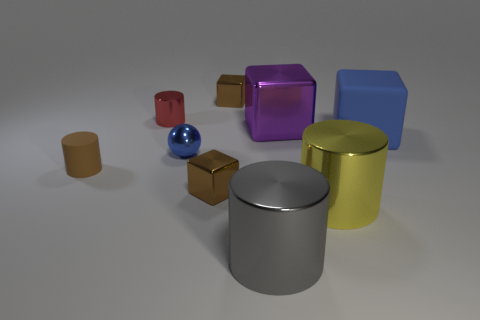There is a rubber object that is the same color as the ball; what size is it?
Provide a succinct answer. Large. There is a tiny shiny block behind the brown matte object; is it the same color as the matte cylinder?
Offer a very short reply. Yes. Is the material of the tiny red cylinder the same as the large blue block?
Your answer should be very brief. No. There is a tiny shiny cube that is behind the small cylinder that is in front of the red metallic cylinder; are there any blue balls right of it?
Offer a very short reply. No. Is the tiny metallic ball the same color as the big matte thing?
Ensure brevity in your answer.  Yes. Are there fewer tiny matte cylinders than objects?
Keep it short and to the point. Yes. Are the cube in front of the brown cylinder and the block that is right of the big yellow metal thing made of the same material?
Provide a short and direct response. No. Are there fewer big blue blocks right of the big blue cube than small cyan shiny things?
Your response must be concise. No. What number of gray objects are behind the tiny brown block that is in front of the brown matte object?
Give a very brief answer. 0. What size is the shiny cylinder that is both left of the yellow cylinder and in front of the large blue cube?
Keep it short and to the point. Large. 